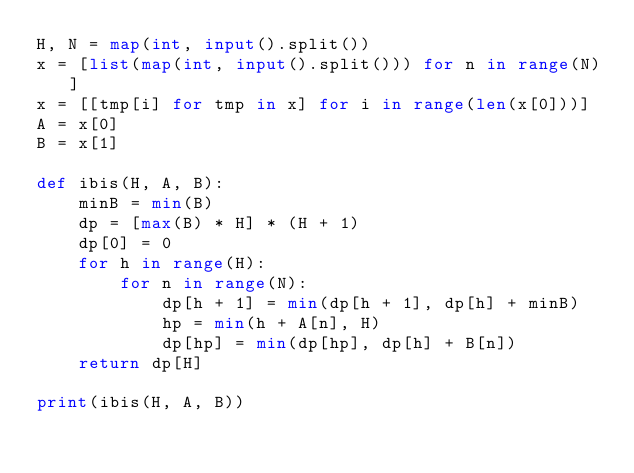Convert code to text. <code><loc_0><loc_0><loc_500><loc_500><_Python_>H, N = map(int, input().split())
x = [list(map(int, input().split())) for n in range(N)]
x = [[tmp[i] for tmp in x] for i in range(len(x[0]))]
A = x[0]
B = x[1]

def ibis(H, A, B):
    minB = min(B)
    dp = [max(B) * H] * (H + 1)
    dp[0] = 0
    for h in range(H):
        for n in range(N):
            dp[h + 1] = min(dp[h + 1], dp[h] + minB)
            hp = min(h + A[n], H)
            dp[hp] = min(dp[hp], dp[h] + B[n])
    return dp[H]

print(ibis(H, A, B))</code> 